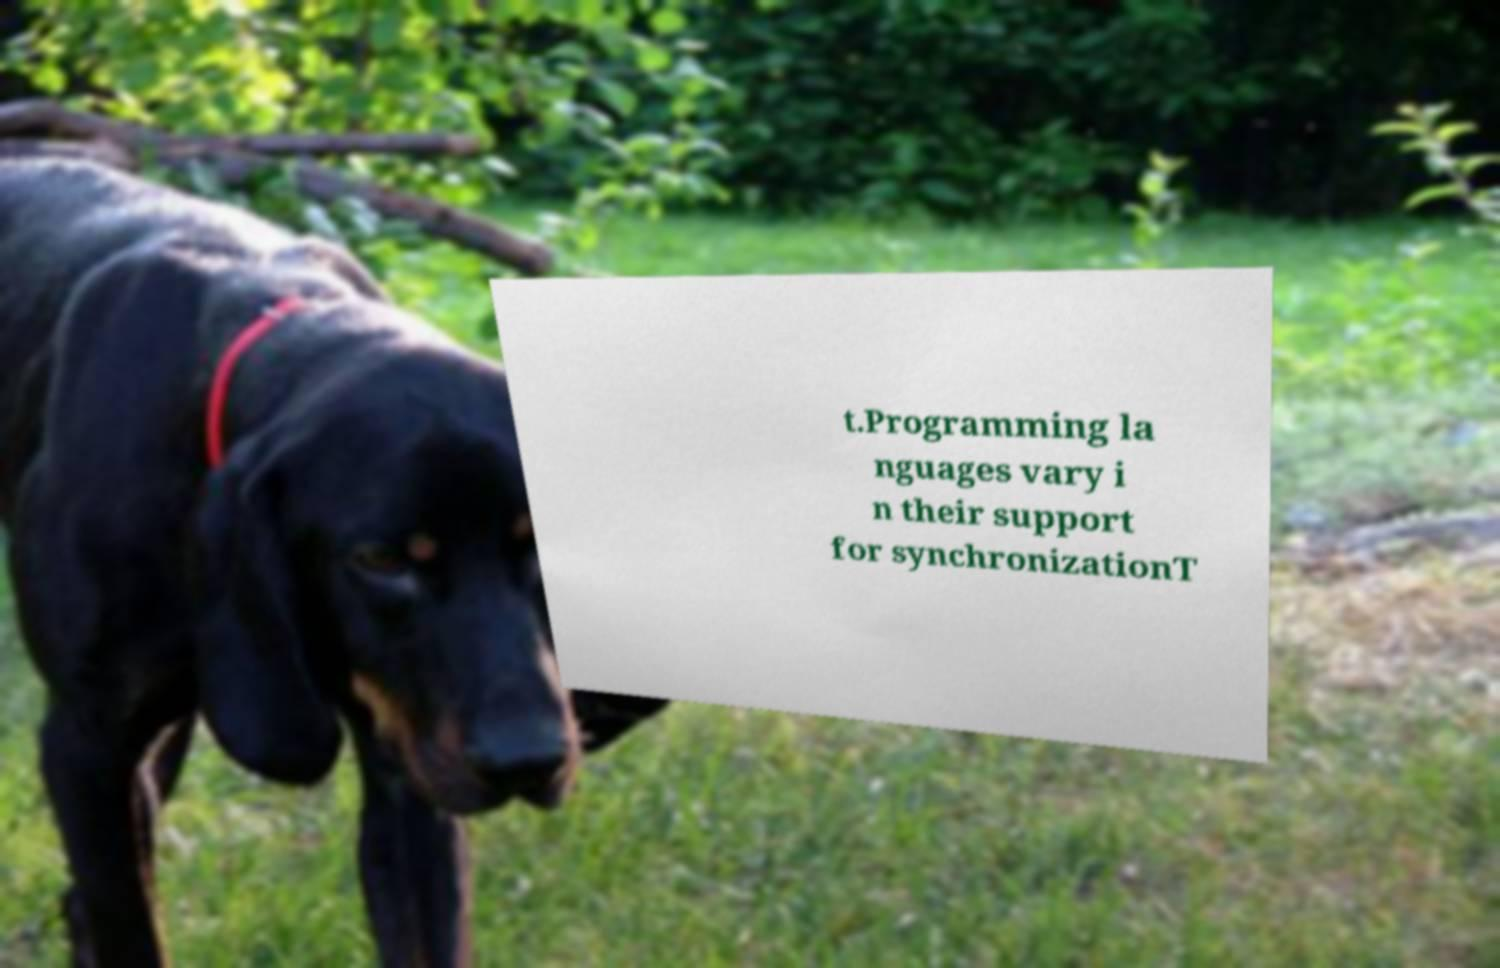Could you extract and type out the text from this image? t.Programming la nguages vary i n their support for synchronizationT 